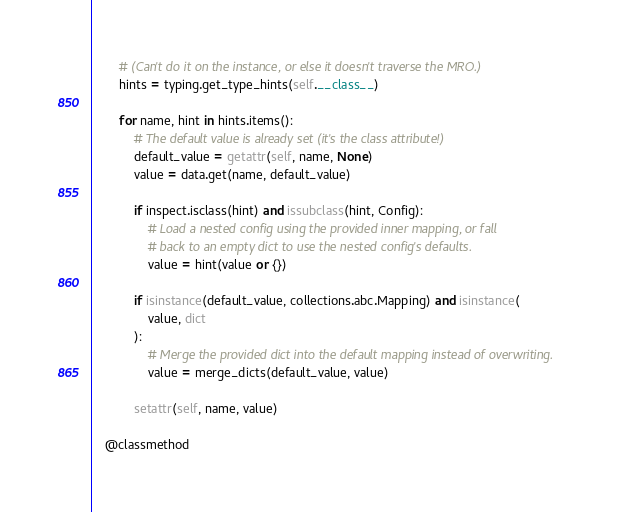Convert code to text. <code><loc_0><loc_0><loc_500><loc_500><_Python_>        # (Can't do it on the instance, or else it doesn't traverse the MRO.)
        hints = typing.get_type_hints(self.__class__)

        for name, hint in hints.items():
            # The default value is already set (it's the class attribute!)
            default_value = getattr(self, name, None)
            value = data.get(name, default_value)

            if inspect.isclass(hint) and issubclass(hint, Config):
                # Load a nested config using the provided inner mapping, or fall
                # back to an empty dict to use the nested config's defaults.
                value = hint(value or {})

            if isinstance(default_value, collections.abc.Mapping) and isinstance(
                value, dict
            ):
                # Merge the provided dict into the default mapping instead of overwriting.
                value = merge_dicts(default_value, value)

            setattr(self, name, value)

    @classmethod</code> 